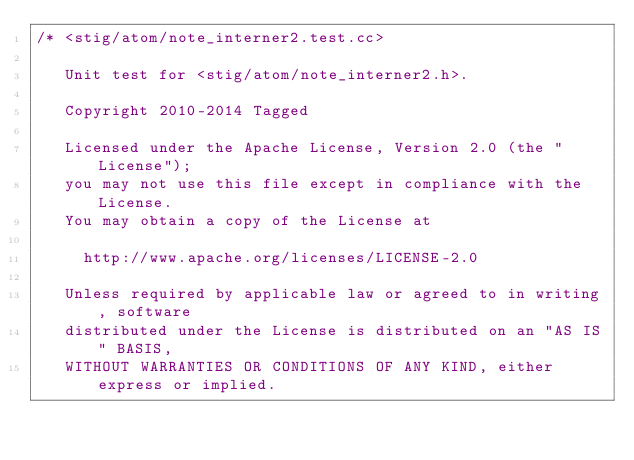Convert code to text. <code><loc_0><loc_0><loc_500><loc_500><_C++_>/* <stig/atom/note_interner2.test.cc> 

   Unit test for <stig/atom/note_interner2.h>.

   Copyright 2010-2014 Tagged
   
   Licensed under the Apache License, Version 2.0 (the "License");
   you may not use this file except in compliance with the License.
   You may obtain a copy of the License at
   
     http://www.apache.org/licenses/LICENSE-2.0
   
   Unless required by applicable law or agreed to in writing, software
   distributed under the License is distributed on an "AS IS" BASIS,
   WITHOUT WARRANTIES OR CONDITIONS OF ANY KIND, either express or implied.</code> 